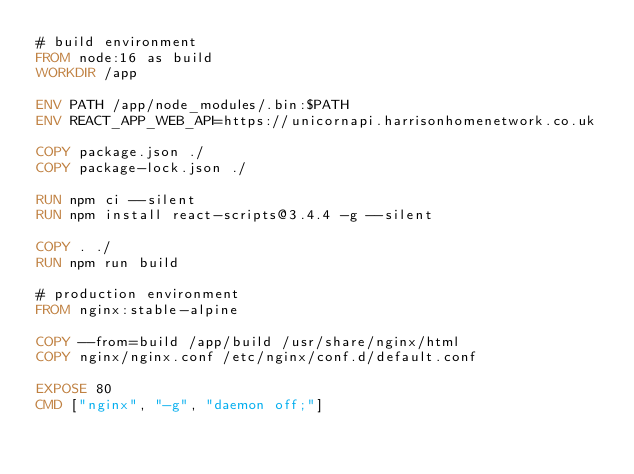<code> <loc_0><loc_0><loc_500><loc_500><_Dockerfile_># build environment
FROM node:16 as build
WORKDIR /app

ENV PATH /app/node_modules/.bin:$PATH
ENV REACT_APP_WEB_API=https://unicornapi.harrisonhomenetwork.co.uk

COPY package.json ./
COPY package-lock.json ./

RUN npm ci --silent
RUN npm install react-scripts@3.4.4 -g --silent

COPY . ./
RUN npm run build

# production environment
FROM nginx:stable-alpine

COPY --from=build /app/build /usr/share/nginx/html
COPY nginx/nginx.conf /etc/nginx/conf.d/default.conf

EXPOSE 80
CMD ["nginx", "-g", "daemon off;"]</code> 